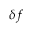<formula> <loc_0><loc_0><loc_500><loc_500>\delta f</formula> 